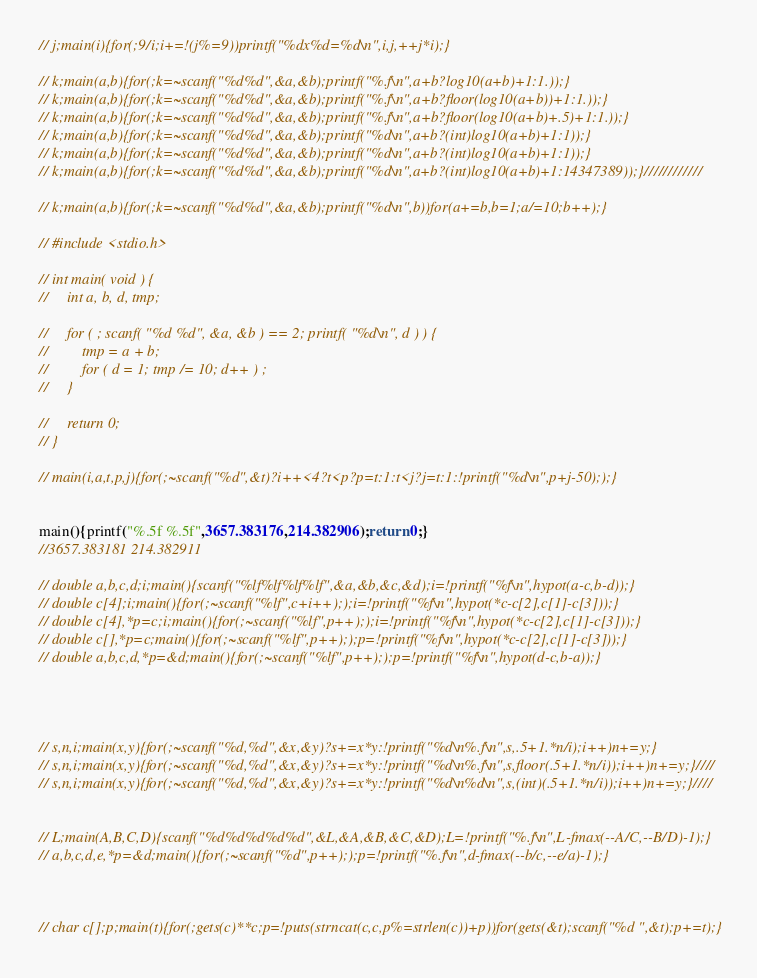<code> <loc_0><loc_0><loc_500><loc_500><_C_>

// j;main(i){for(;9/i;i+=!(j%=9))printf("%dx%d=%d\n",i,j,++j*i);}

// k;main(a,b){for(;k=~scanf("%d%d",&a,&b);printf("%.f\n",a+b?log10(a+b)+1:1.));}
// k;main(a,b){for(;k=~scanf("%d%d",&a,&b);printf("%.f\n",a+b?floor(log10(a+b))+1:1.));}
// k;main(a,b){for(;k=~scanf("%d%d",&a,&b);printf("%.f\n",a+b?floor(log10(a+b)+.5)+1:1.));}
// k;main(a,b){for(;k=~scanf("%d%d",&a,&b);printf("%d\n",a+b?(int)log10(a+b)+1:1));}
// k;main(a,b){for(;k=~scanf("%d%d",&a,&b);printf("%d\n",a+b?(int)log10(a+b)+1:1));}
// k;main(a,b){for(;k=~scanf("%d%d",&a,&b);printf("%d\n",a+b?(int)log10(a+b)+1:14347389));}////////////

// k;main(a,b){for(;k=~scanf("%d%d",&a,&b);printf("%d\n",b))for(a+=b,b=1;a/=10;b++);}

// #include <stdio.h>
 
// int main( void ) {
//     int a, b, d, tmp;
 
//     for ( ; scanf( "%d %d", &a, &b ) == 2; printf( "%d\n", d ) ) {
//         tmp = a + b;
//         for ( d = 1; tmp /= 10; d++ ) ;
//     }
 
//     return 0;
// }

// main(i,a,t,p,j){for(;~scanf("%d",&t)?i++<4?t<p?p=t:1:t<j?j=t:1:!printf("%d\n",p+j-50););}


main(){printf("%.5f %.5f",3657.383176,214.382906);return 0;}
//3657.383181 214.382911

// double a,b,c,d;i;main(){scanf("%lf%lf%lf%lf",&a,&b,&c,&d);i=!printf("%f\n",hypot(a-c,b-d));}
// double c[4];i;main(){for(;~scanf("%lf",c+i++););i=!printf("%f\n",hypot(*c-c[2],c[1]-c[3]));}
// double c[4],*p=c;i;main(){for(;~scanf("%lf",p++););i=!printf("%f\n",hypot(*c-c[2],c[1]-c[3]));}
// double c[],*p=c;main(){for(;~scanf("%lf",p++););p=!printf("%f\n",hypot(*c-c[2],c[1]-c[3]));}
// double a,b,c,d,*p=&d;main(){for(;~scanf("%lf",p++););p=!printf("%f\n",hypot(d-c,b-a));}




// s,n,i;main(x,y){for(;~scanf("%d,%d",&x,&y)?s+=x*y:!printf("%d\n%.f\n",s,.5+1.*n/i);i++)n+=y;}
// s,n,i;main(x,y){for(;~scanf("%d,%d",&x,&y)?s+=x*y:!printf("%d\n%.f\n",s,floor(.5+1.*n/i));i++)n+=y;}////
// s,n,i;main(x,y){for(;~scanf("%d,%d",&x,&y)?s+=x*y:!printf("%d\n%d\n",s,(int)(.5+1.*n/i));i++)n+=y;}////


// L;main(A,B,C,D){scanf("%d%d%d%d%d",&L,&A,&B,&C,&D);L=!printf("%.f\n",L-fmax(--A/C,--B/D)-1);}
// a,b,c,d,e,*p=&d;main(){for(;~scanf("%d",p++););p=!printf("%.f\n",d-fmax(--b/c,--e/a)-1);}



// char c[];p;main(t){for(;gets(c)**c;p=!puts(strncat(c,c,p%=strlen(c))+p))for(gets(&t);scanf("%d ",&t);p+=t);}</code> 